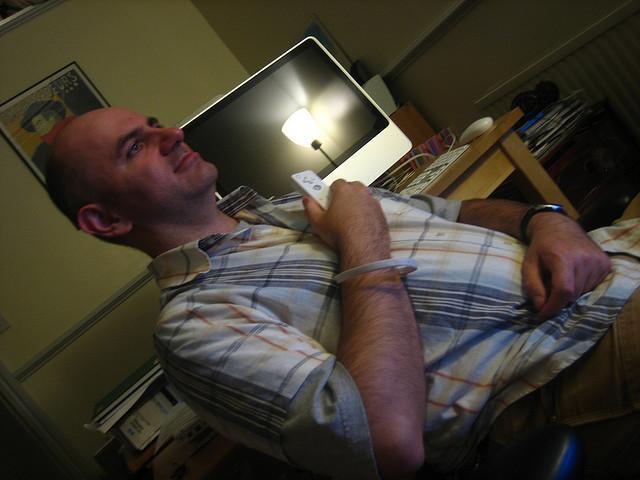How many people are in the picture?
Give a very brief answer. 1. 